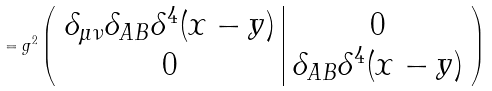<formula> <loc_0><loc_0><loc_500><loc_500>= g ^ { 2 } \left ( \begin{array} { c | c } \delta _ { \mu \nu } \delta _ { A B } \delta ^ { 4 } ( x - y ) & 0 \\ 0 & \delta _ { A B } \delta ^ { 4 } ( x - y ) \end{array} \right )</formula> 